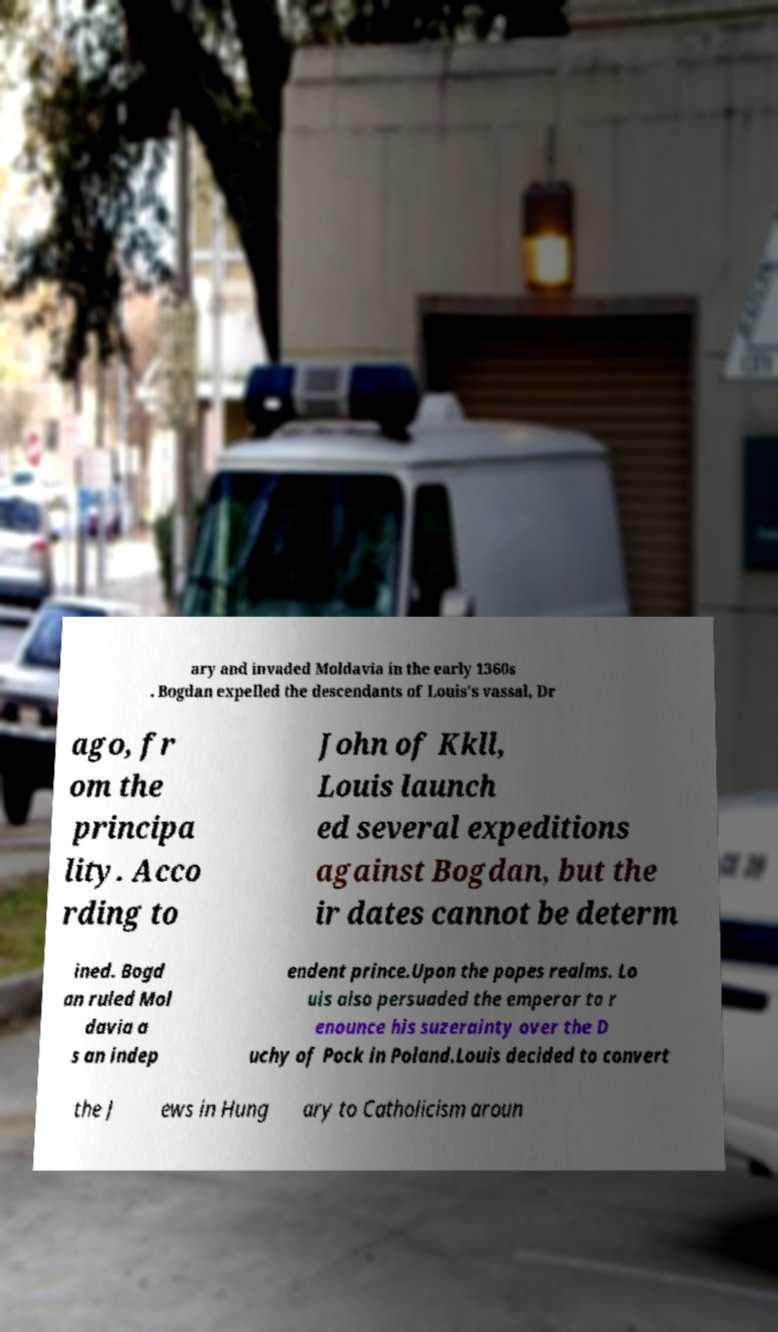Can you read and provide the text displayed in the image?This photo seems to have some interesting text. Can you extract and type it out for me? ary and invaded Moldavia in the early 1360s . Bogdan expelled the descendants of Louis's vassal, Dr ago, fr om the principa lity. Acco rding to John of Kkll, Louis launch ed several expeditions against Bogdan, but the ir dates cannot be determ ined. Bogd an ruled Mol davia a s an indep endent prince.Upon the popes realms. Lo uis also persuaded the emperor to r enounce his suzerainty over the D uchy of Pock in Poland.Louis decided to convert the J ews in Hung ary to Catholicism aroun 